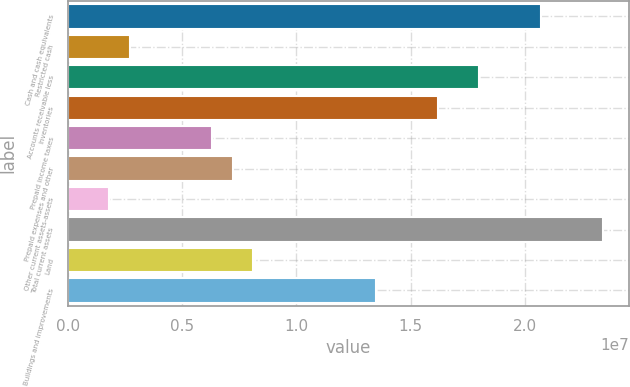Convert chart. <chart><loc_0><loc_0><loc_500><loc_500><bar_chart><fcel>Cash and cash equivalents<fcel>Restricted cash<fcel>Accounts receivable less<fcel>Inventories<fcel>Prepaid income taxes<fcel>Prepaid expenses and other<fcel>Other current assets-assets<fcel>Total current assets<fcel>Land<fcel>Buildings and improvements<nl><fcel>2.06999e+07<fcel>2.70131e+06<fcel>1.80001e+07<fcel>1.62003e+07<fcel>6.30103e+06<fcel>7.20096e+06<fcel>1.80138e+06<fcel>2.33997e+07<fcel>8.10089e+06<fcel>1.35005e+07<nl></chart> 